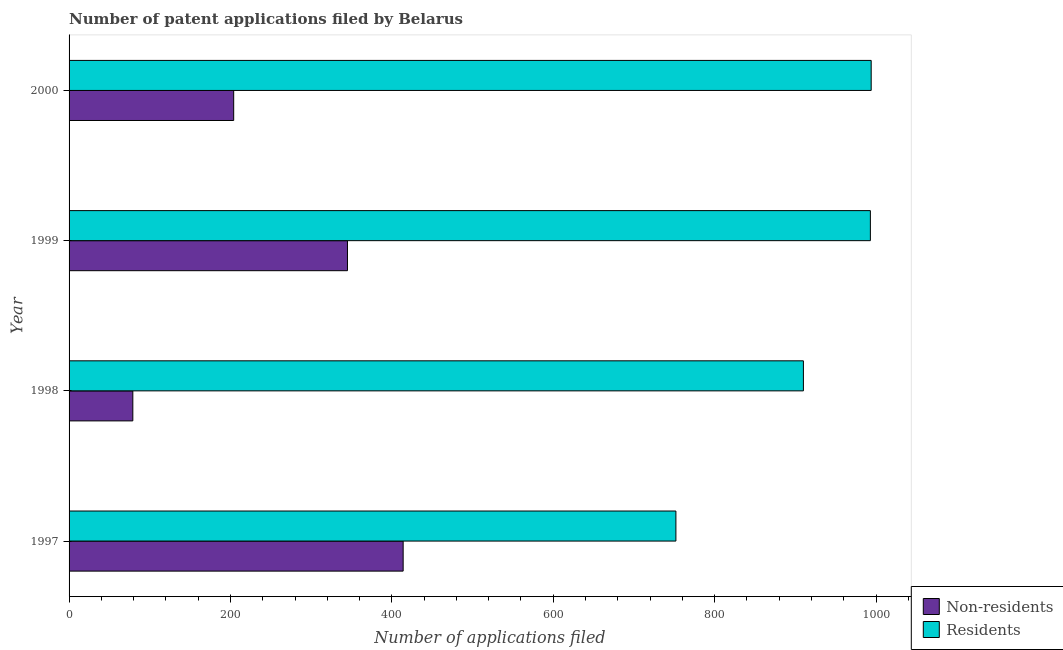How many groups of bars are there?
Your answer should be compact. 4. Are the number of bars per tick equal to the number of legend labels?
Provide a short and direct response. Yes. Are the number of bars on each tick of the Y-axis equal?
Offer a terse response. Yes. How many bars are there on the 4th tick from the top?
Your response must be concise. 2. How many bars are there on the 1st tick from the bottom?
Your response must be concise. 2. In how many cases, is the number of bars for a given year not equal to the number of legend labels?
Give a very brief answer. 0. What is the number of patent applications by non residents in 1999?
Keep it short and to the point. 345. Across all years, what is the maximum number of patent applications by non residents?
Your answer should be compact. 414. Across all years, what is the minimum number of patent applications by non residents?
Keep it short and to the point. 79. In which year was the number of patent applications by residents minimum?
Offer a very short reply. 1997. What is the total number of patent applications by non residents in the graph?
Provide a short and direct response. 1042. What is the difference between the number of patent applications by residents in 1999 and that in 2000?
Offer a very short reply. -1. What is the difference between the number of patent applications by residents in 1998 and the number of patent applications by non residents in 1997?
Provide a succinct answer. 496. What is the average number of patent applications by non residents per year?
Make the answer very short. 260.5. In the year 1998, what is the difference between the number of patent applications by residents and number of patent applications by non residents?
Your answer should be compact. 831. In how many years, is the number of patent applications by residents greater than 880 ?
Provide a succinct answer. 3. What is the ratio of the number of patent applications by non residents in 1998 to that in 1999?
Offer a very short reply. 0.23. Is the number of patent applications by residents in 1998 less than that in 1999?
Your answer should be very brief. Yes. Is the difference between the number of patent applications by non residents in 1998 and 1999 greater than the difference between the number of patent applications by residents in 1998 and 1999?
Provide a succinct answer. No. What is the difference between the highest and the lowest number of patent applications by residents?
Make the answer very short. 242. In how many years, is the number of patent applications by residents greater than the average number of patent applications by residents taken over all years?
Keep it short and to the point. 2. Is the sum of the number of patent applications by residents in 1998 and 2000 greater than the maximum number of patent applications by non residents across all years?
Keep it short and to the point. Yes. What does the 2nd bar from the top in 1997 represents?
Ensure brevity in your answer.  Non-residents. What does the 1st bar from the bottom in 1997 represents?
Give a very brief answer. Non-residents. How many bars are there?
Your answer should be very brief. 8. How many years are there in the graph?
Offer a very short reply. 4. What is the difference between two consecutive major ticks on the X-axis?
Your answer should be very brief. 200. Does the graph contain any zero values?
Make the answer very short. No. Where does the legend appear in the graph?
Offer a terse response. Bottom right. How many legend labels are there?
Keep it short and to the point. 2. How are the legend labels stacked?
Your answer should be compact. Vertical. What is the title of the graph?
Provide a succinct answer. Number of patent applications filed by Belarus. Does "Subsidies" appear as one of the legend labels in the graph?
Make the answer very short. No. What is the label or title of the X-axis?
Your answer should be very brief. Number of applications filed. What is the Number of applications filed of Non-residents in 1997?
Make the answer very short. 414. What is the Number of applications filed in Residents in 1997?
Offer a very short reply. 752. What is the Number of applications filed in Non-residents in 1998?
Provide a short and direct response. 79. What is the Number of applications filed of Residents in 1998?
Your answer should be very brief. 910. What is the Number of applications filed in Non-residents in 1999?
Your answer should be very brief. 345. What is the Number of applications filed of Residents in 1999?
Make the answer very short. 993. What is the Number of applications filed of Non-residents in 2000?
Offer a very short reply. 204. What is the Number of applications filed in Residents in 2000?
Ensure brevity in your answer.  994. Across all years, what is the maximum Number of applications filed of Non-residents?
Ensure brevity in your answer.  414. Across all years, what is the maximum Number of applications filed in Residents?
Give a very brief answer. 994. Across all years, what is the minimum Number of applications filed in Non-residents?
Keep it short and to the point. 79. Across all years, what is the minimum Number of applications filed of Residents?
Make the answer very short. 752. What is the total Number of applications filed in Non-residents in the graph?
Provide a short and direct response. 1042. What is the total Number of applications filed of Residents in the graph?
Give a very brief answer. 3649. What is the difference between the Number of applications filed of Non-residents in 1997 and that in 1998?
Ensure brevity in your answer.  335. What is the difference between the Number of applications filed of Residents in 1997 and that in 1998?
Provide a succinct answer. -158. What is the difference between the Number of applications filed of Residents in 1997 and that in 1999?
Your answer should be very brief. -241. What is the difference between the Number of applications filed of Non-residents in 1997 and that in 2000?
Your answer should be very brief. 210. What is the difference between the Number of applications filed of Residents in 1997 and that in 2000?
Make the answer very short. -242. What is the difference between the Number of applications filed of Non-residents in 1998 and that in 1999?
Provide a succinct answer. -266. What is the difference between the Number of applications filed of Residents in 1998 and that in 1999?
Make the answer very short. -83. What is the difference between the Number of applications filed of Non-residents in 1998 and that in 2000?
Make the answer very short. -125. What is the difference between the Number of applications filed of Residents in 1998 and that in 2000?
Make the answer very short. -84. What is the difference between the Number of applications filed of Non-residents in 1999 and that in 2000?
Keep it short and to the point. 141. What is the difference between the Number of applications filed of Residents in 1999 and that in 2000?
Keep it short and to the point. -1. What is the difference between the Number of applications filed in Non-residents in 1997 and the Number of applications filed in Residents in 1998?
Offer a terse response. -496. What is the difference between the Number of applications filed in Non-residents in 1997 and the Number of applications filed in Residents in 1999?
Your response must be concise. -579. What is the difference between the Number of applications filed of Non-residents in 1997 and the Number of applications filed of Residents in 2000?
Make the answer very short. -580. What is the difference between the Number of applications filed of Non-residents in 1998 and the Number of applications filed of Residents in 1999?
Keep it short and to the point. -914. What is the difference between the Number of applications filed in Non-residents in 1998 and the Number of applications filed in Residents in 2000?
Offer a very short reply. -915. What is the difference between the Number of applications filed in Non-residents in 1999 and the Number of applications filed in Residents in 2000?
Offer a very short reply. -649. What is the average Number of applications filed in Non-residents per year?
Your response must be concise. 260.5. What is the average Number of applications filed of Residents per year?
Your answer should be compact. 912.25. In the year 1997, what is the difference between the Number of applications filed of Non-residents and Number of applications filed of Residents?
Give a very brief answer. -338. In the year 1998, what is the difference between the Number of applications filed of Non-residents and Number of applications filed of Residents?
Provide a short and direct response. -831. In the year 1999, what is the difference between the Number of applications filed in Non-residents and Number of applications filed in Residents?
Keep it short and to the point. -648. In the year 2000, what is the difference between the Number of applications filed of Non-residents and Number of applications filed of Residents?
Offer a very short reply. -790. What is the ratio of the Number of applications filed in Non-residents in 1997 to that in 1998?
Provide a succinct answer. 5.24. What is the ratio of the Number of applications filed in Residents in 1997 to that in 1998?
Your answer should be compact. 0.83. What is the ratio of the Number of applications filed of Non-residents in 1997 to that in 1999?
Provide a succinct answer. 1.2. What is the ratio of the Number of applications filed in Residents in 1997 to that in 1999?
Your response must be concise. 0.76. What is the ratio of the Number of applications filed of Non-residents in 1997 to that in 2000?
Make the answer very short. 2.03. What is the ratio of the Number of applications filed in Residents in 1997 to that in 2000?
Offer a terse response. 0.76. What is the ratio of the Number of applications filed of Non-residents in 1998 to that in 1999?
Your answer should be very brief. 0.23. What is the ratio of the Number of applications filed in Residents in 1998 to that in 1999?
Provide a short and direct response. 0.92. What is the ratio of the Number of applications filed in Non-residents in 1998 to that in 2000?
Offer a very short reply. 0.39. What is the ratio of the Number of applications filed in Residents in 1998 to that in 2000?
Offer a terse response. 0.92. What is the ratio of the Number of applications filed of Non-residents in 1999 to that in 2000?
Your answer should be very brief. 1.69. What is the difference between the highest and the lowest Number of applications filed of Non-residents?
Provide a succinct answer. 335. What is the difference between the highest and the lowest Number of applications filed in Residents?
Keep it short and to the point. 242. 